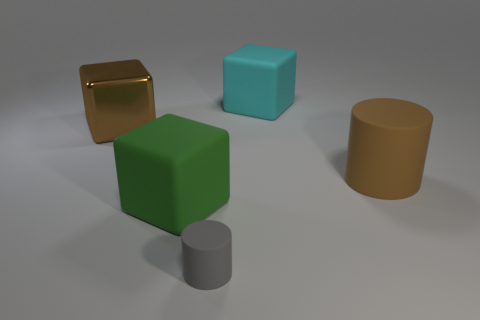Is there any other thing that is the same size as the metallic block?
Your answer should be very brief. Yes. Does the metal thing have the same color as the big matte cylinder?
Your answer should be very brief. Yes. How many cyan things are to the right of the cyan rubber block?
Offer a terse response. 0. What number of large rubber cylinders have the same color as the large shiny cube?
Your answer should be compact. 1. How many objects are either things in front of the shiny block or blocks behind the large brown block?
Ensure brevity in your answer.  4. Are there more brown matte objects than large things?
Your response must be concise. No. There is a matte block that is left of the gray matte thing; what color is it?
Offer a terse response. Green. Is the green thing the same shape as the gray rubber thing?
Give a very brief answer. No. There is a large object that is behind the large matte cylinder and on the right side of the tiny cylinder; what color is it?
Ensure brevity in your answer.  Cyan. There is a matte object that is to the left of the gray rubber thing; is its size the same as the gray rubber cylinder that is on the left side of the big cyan rubber block?
Provide a succinct answer. No. 